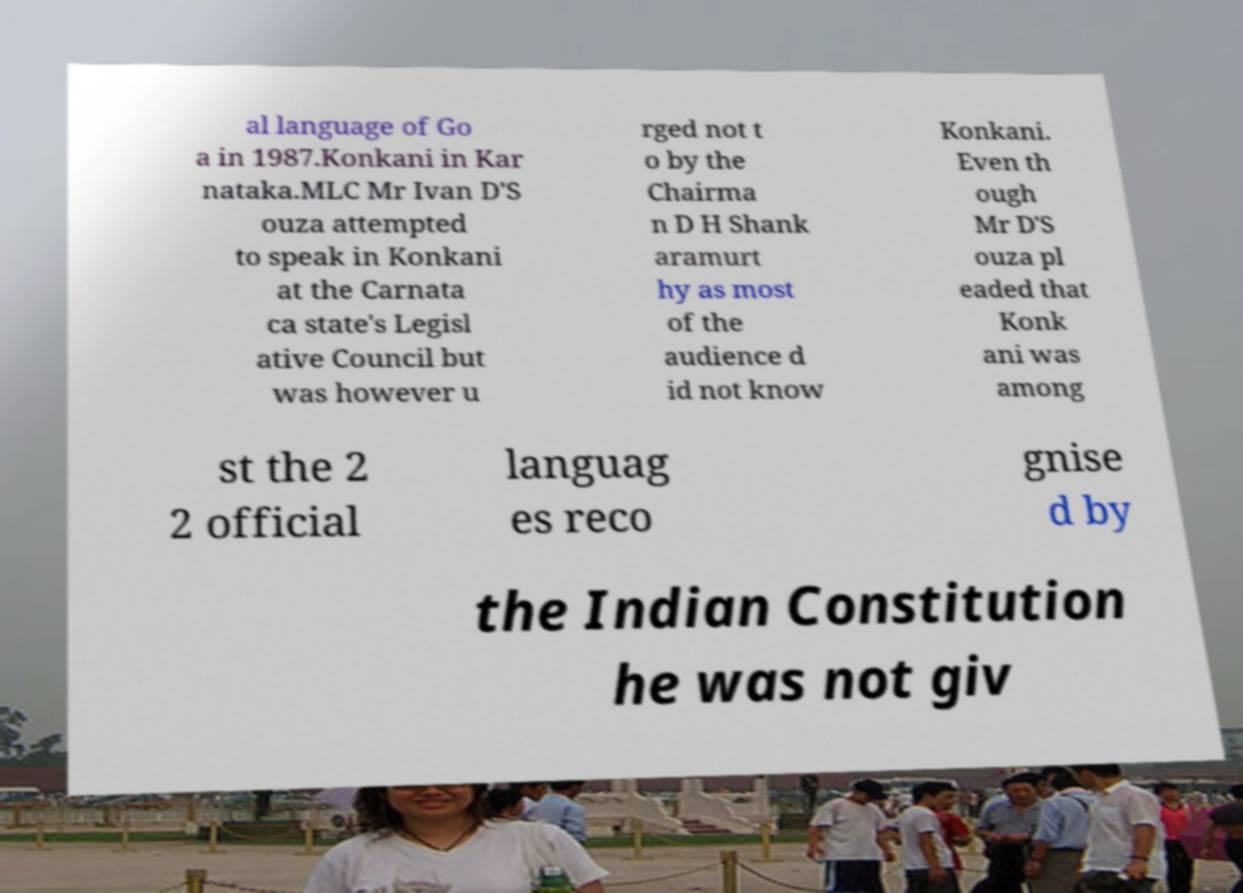Could you extract and type out the text from this image? al language of Go a in 1987.Konkani in Kar nataka.MLC Mr Ivan D'S ouza attempted to speak in Konkani at the Carnata ca state's Legisl ative Council but was however u rged not t o by the Chairma n D H Shank aramurt hy as most of the audience d id not know Konkani. Even th ough Mr D'S ouza pl eaded that Konk ani was among st the 2 2 official languag es reco gnise d by the Indian Constitution he was not giv 